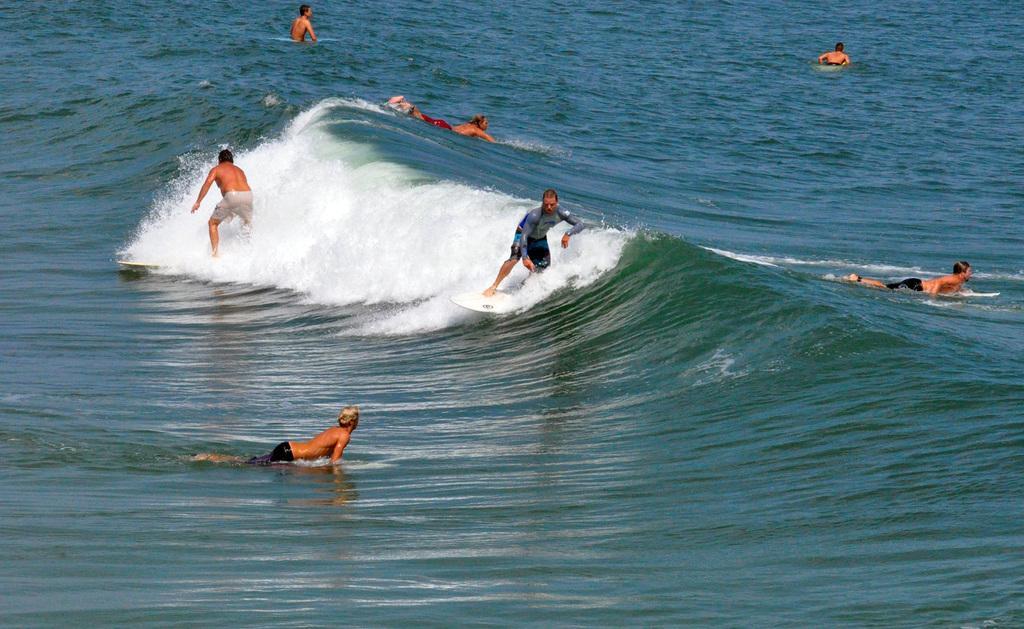How would you summarize this image in a sentence or two? In this image we can see people surfing in water. 